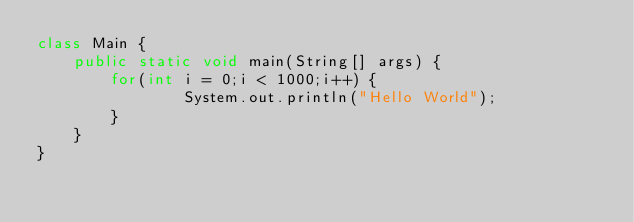<code> <loc_0><loc_0><loc_500><loc_500><_Java_>class Main {
    public static void main(String[] args) {
        for(int i = 0;i < 1000;i++) {
                System.out.println("Hello World");
        }
    }
}</code> 